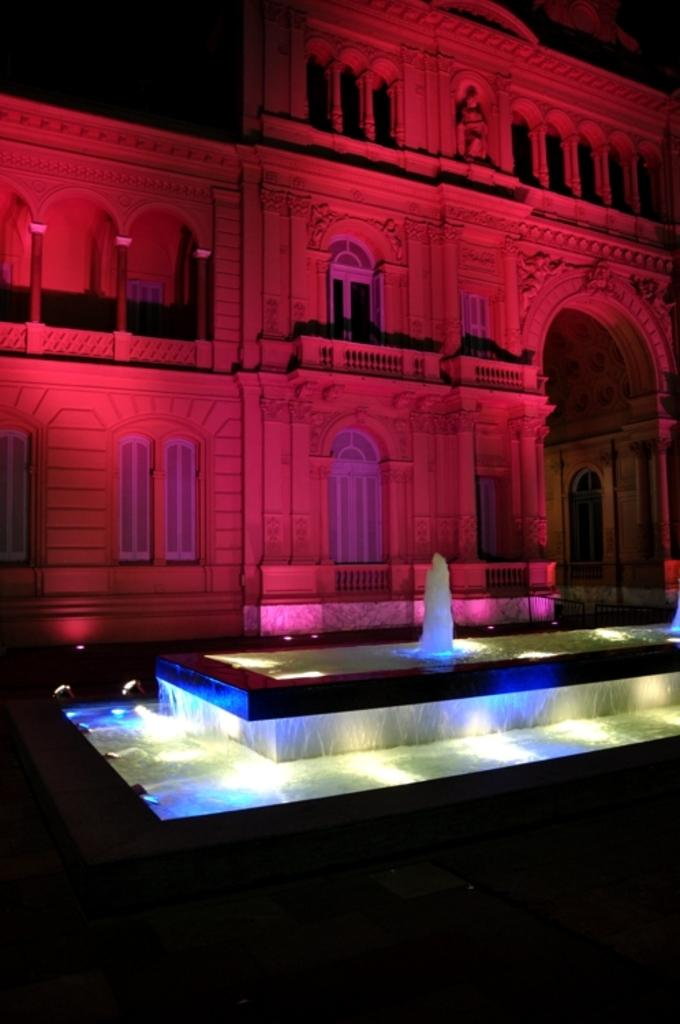What is the main subject in the center of the image? There is a fountain in the center of the image. What can be seen in the background of the image? There is a building, pillars, windows, and sculptures visible in the background of the image. What is the tendency of the fan in the image? There is no fan present in the image. What type of branch can be seen growing from the sculpture in the image? There are no branches visible in the image, and the sculptures do not appear to be growing anything. 